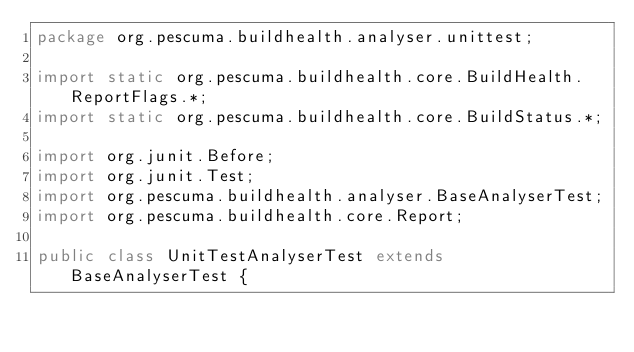Convert code to text. <code><loc_0><loc_0><loc_500><loc_500><_Java_>package org.pescuma.buildhealth.analyser.unittest;

import static org.pescuma.buildhealth.core.BuildHealth.ReportFlags.*;
import static org.pescuma.buildhealth.core.BuildStatus.*;

import org.junit.Before;
import org.junit.Test;
import org.pescuma.buildhealth.analyser.BaseAnalyserTest;
import org.pescuma.buildhealth.core.Report;

public class UnitTestAnalyserTest extends BaseAnalyserTest {
	</code> 